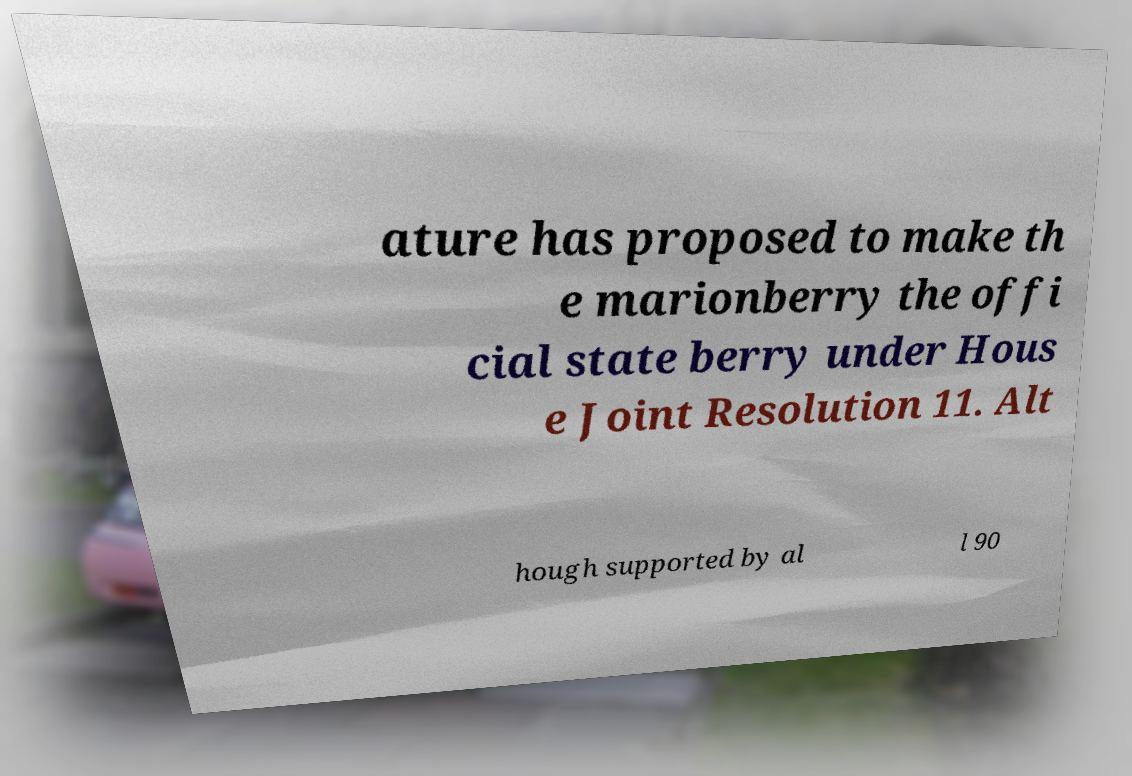Could you assist in decoding the text presented in this image and type it out clearly? ature has proposed to make th e marionberry the offi cial state berry under Hous e Joint Resolution 11. Alt hough supported by al l 90 